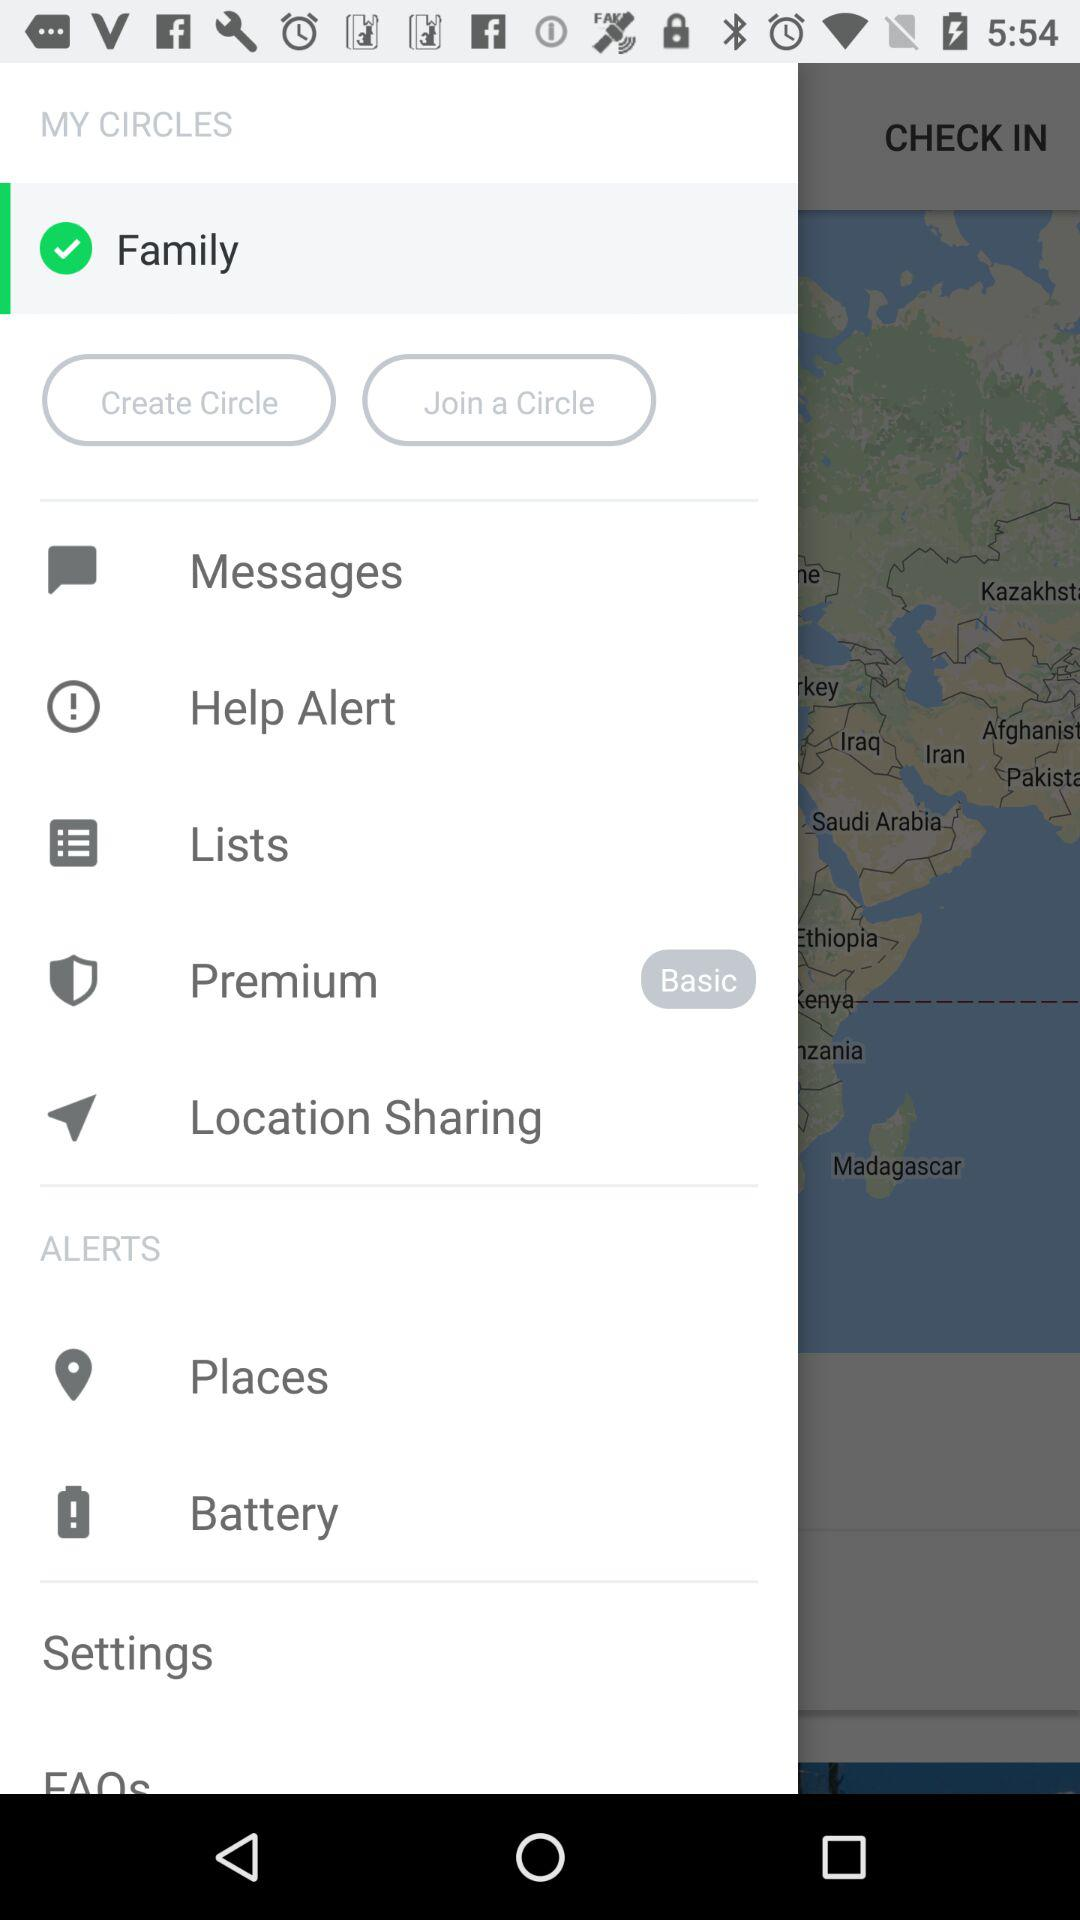How many items are in the My Circles section?
Answer the question using a single word or phrase. 6 